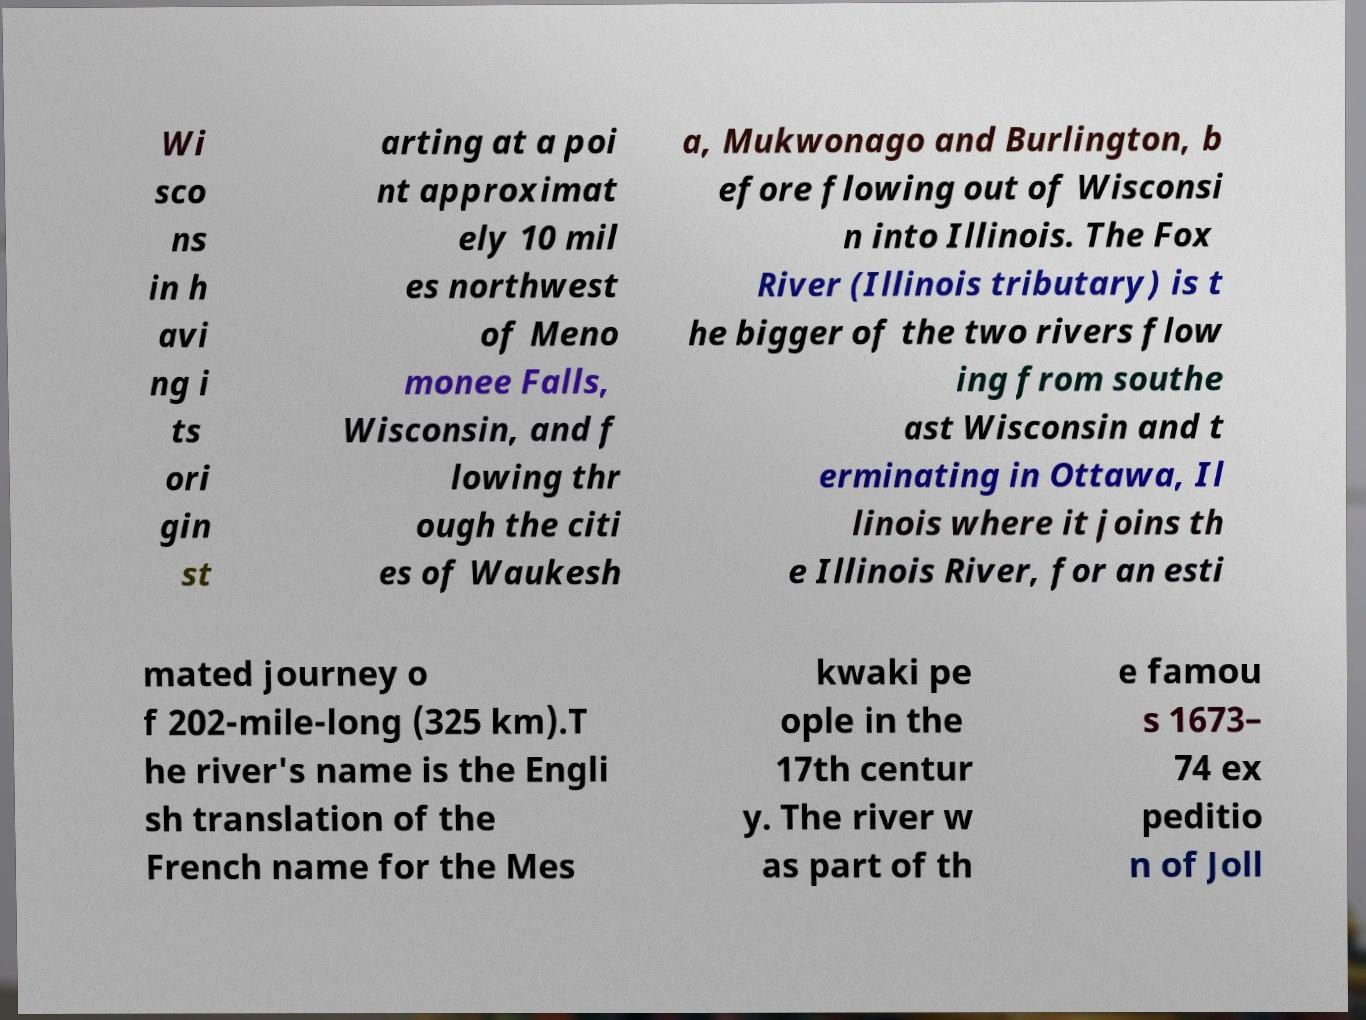Please identify and transcribe the text found in this image. Wi sco ns in h avi ng i ts ori gin st arting at a poi nt approximat ely 10 mil es northwest of Meno monee Falls, Wisconsin, and f lowing thr ough the citi es of Waukesh a, Mukwonago and Burlington, b efore flowing out of Wisconsi n into Illinois. The Fox River (Illinois tributary) is t he bigger of the two rivers flow ing from southe ast Wisconsin and t erminating in Ottawa, Il linois where it joins th e Illinois River, for an esti mated journey o f 202-mile-long (325 km).T he river's name is the Engli sh translation of the French name for the Mes kwaki pe ople in the 17th centur y. The river w as part of th e famou s 1673– 74 ex peditio n of Joll 